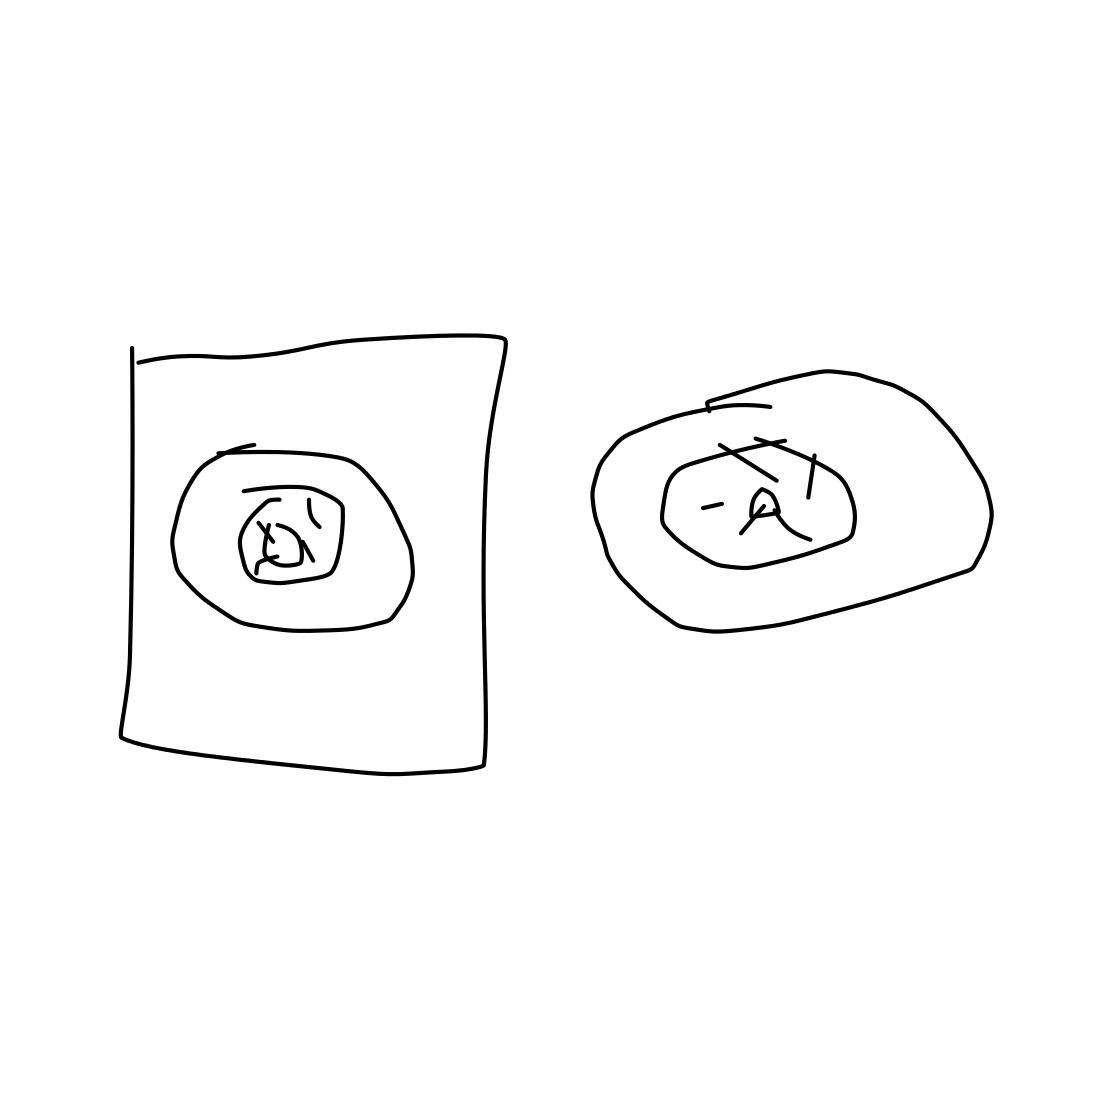Is there a sketchy loudspeaker in the picture? While the image contains rough sketches that could be interpreted as objects with speakers, it is not clear enough to definitively identify them as loudspeakers. They appear to be basic drawings possibly representing speakers or another type of electronic device. 